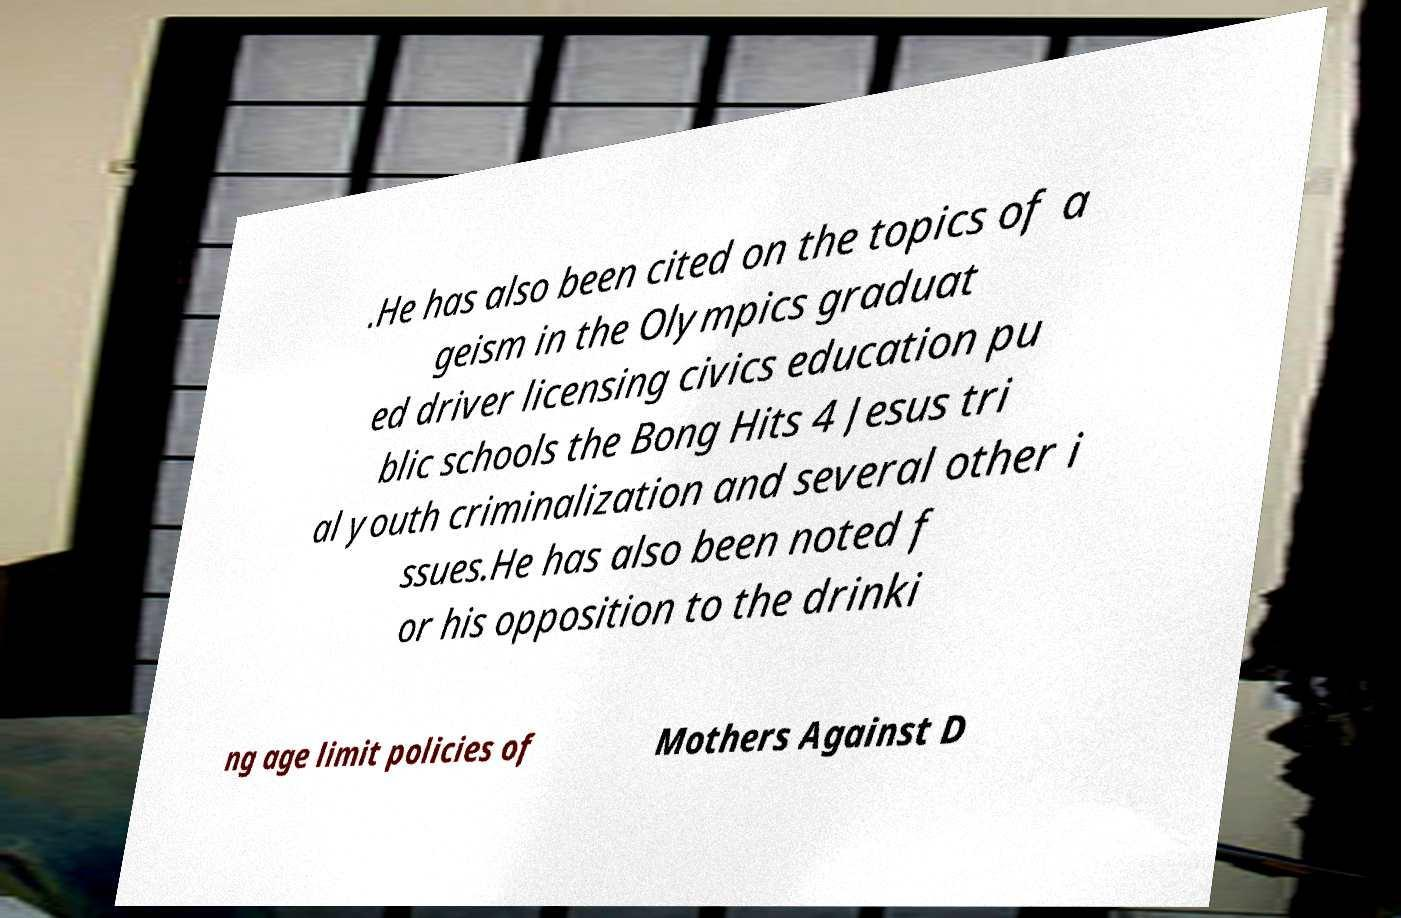Please identify and transcribe the text found in this image. .He has also been cited on the topics of a geism in the Olympics graduat ed driver licensing civics education pu blic schools the Bong Hits 4 Jesus tri al youth criminalization and several other i ssues.He has also been noted f or his opposition to the drinki ng age limit policies of Mothers Against D 